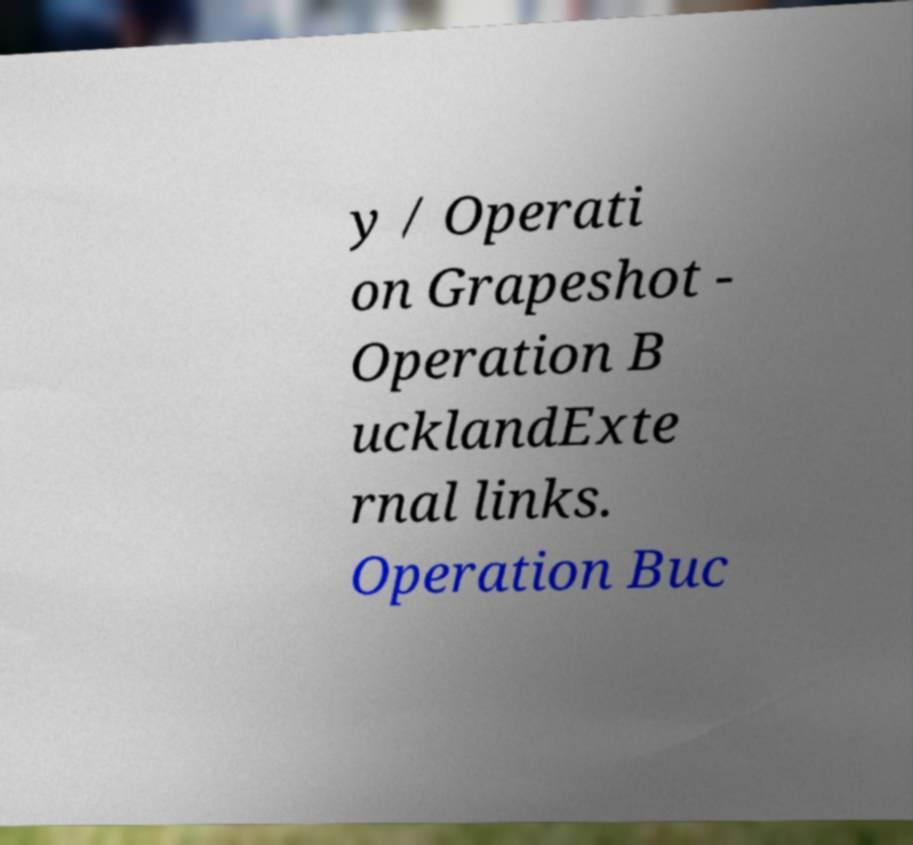For documentation purposes, I need the text within this image transcribed. Could you provide that? y / Operati on Grapeshot - Operation B ucklandExte rnal links. Operation Buc 